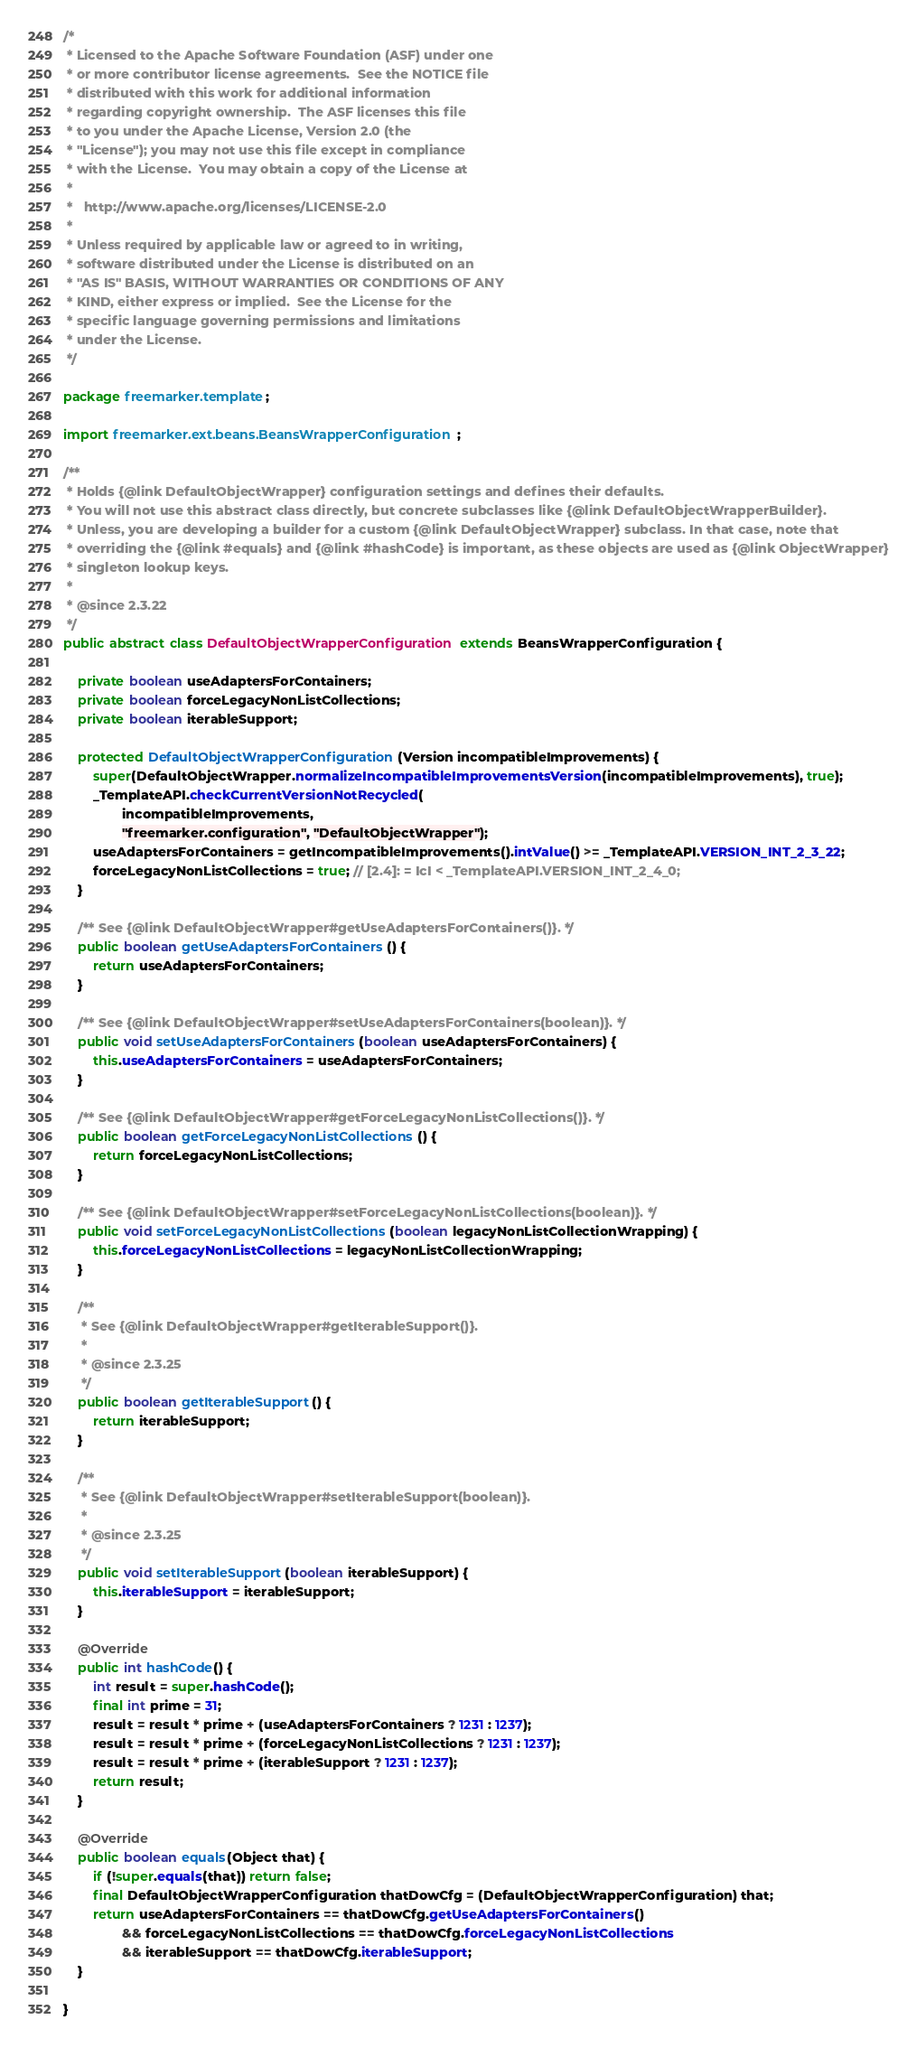<code> <loc_0><loc_0><loc_500><loc_500><_Java_>/*
 * Licensed to the Apache Software Foundation (ASF) under one
 * or more contributor license agreements.  See the NOTICE file
 * distributed with this work for additional information
 * regarding copyright ownership.  The ASF licenses this file
 * to you under the Apache License, Version 2.0 (the
 * "License"); you may not use this file except in compliance
 * with the License.  You may obtain a copy of the License at
 *
 *   http://www.apache.org/licenses/LICENSE-2.0
 *
 * Unless required by applicable law or agreed to in writing,
 * software distributed under the License is distributed on an
 * "AS IS" BASIS, WITHOUT WARRANTIES OR CONDITIONS OF ANY
 * KIND, either express or implied.  See the License for the
 * specific language governing permissions and limitations
 * under the License.
 */

package freemarker.template;

import freemarker.ext.beans.BeansWrapperConfiguration;

/**
 * Holds {@link DefaultObjectWrapper} configuration settings and defines their defaults.
 * You will not use this abstract class directly, but concrete subclasses like {@link DefaultObjectWrapperBuilder}.
 * Unless, you are developing a builder for a custom {@link DefaultObjectWrapper} subclass. In that case, note that
 * overriding the {@link #equals} and {@link #hashCode} is important, as these objects are used as {@link ObjectWrapper}
 * singleton lookup keys.
 * 
 * @since 2.3.22
 */
public abstract class DefaultObjectWrapperConfiguration extends BeansWrapperConfiguration {
    
    private boolean useAdaptersForContainers;
    private boolean forceLegacyNonListCollections;
    private boolean iterableSupport;

    protected DefaultObjectWrapperConfiguration(Version incompatibleImprovements) {
        super(DefaultObjectWrapper.normalizeIncompatibleImprovementsVersion(incompatibleImprovements), true);
        _TemplateAPI.checkCurrentVersionNotRecycled(
                incompatibleImprovements,
                "freemarker.configuration", "DefaultObjectWrapper");
        useAdaptersForContainers = getIncompatibleImprovements().intValue() >= _TemplateAPI.VERSION_INT_2_3_22;
        forceLegacyNonListCollections = true; // [2.4]: = IcI < _TemplateAPI.VERSION_INT_2_4_0;
    }

    /** See {@link DefaultObjectWrapper#getUseAdaptersForContainers()}. */
    public boolean getUseAdaptersForContainers() {
        return useAdaptersForContainers;
    }

    /** See {@link DefaultObjectWrapper#setUseAdaptersForContainers(boolean)}. */
    public void setUseAdaptersForContainers(boolean useAdaptersForContainers) {
        this.useAdaptersForContainers = useAdaptersForContainers;
    }
    
    /** See {@link DefaultObjectWrapper#getForceLegacyNonListCollections()}. */
    public boolean getForceLegacyNonListCollections() {
        return forceLegacyNonListCollections;
    }

    /** See {@link DefaultObjectWrapper#setForceLegacyNonListCollections(boolean)}. */
    public void setForceLegacyNonListCollections(boolean legacyNonListCollectionWrapping) {
        this.forceLegacyNonListCollections = legacyNonListCollectionWrapping;
    }

    /**
     * See {@link DefaultObjectWrapper#getIterableSupport()}.
     * 
     * @since 2.3.25 
     */
    public boolean getIterableSupport() {
        return iterableSupport;
    }

    /**
     * See {@link DefaultObjectWrapper#setIterableSupport(boolean)}.
     * 
     * @since 2.3.25 
     */
    public void setIterableSupport(boolean iterableSupport) {
        this.iterableSupport = iterableSupport;
    }
    
    @Override
    public int hashCode() {
        int result = super.hashCode();
        final int prime = 31;
        result = result * prime + (useAdaptersForContainers ? 1231 : 1237);
        result = result * prime + (forceLegacyNonListCollections ? 1231 : 1237);
        result = result * prime + (iterableSupport ? 1231 : 1237);
        return result;
    }

    @Override
    public boolean equals(Object that) {
        if (!super.equals(that)) return false;
        final DefaultObjectWrapperConfiguration thatDowCfg = (DefaultObjectWrapperConfiguration) that;
        return useAdaptersForContainers == thatDowCfg.getUseAdaptersForContainers()
                && forceLegacyNonListCollections == thatDowCfg.forceLegacyNonListCollections
                && iterableSupport == thatDowCfg.iterableSupport;
    }

}
</code> 